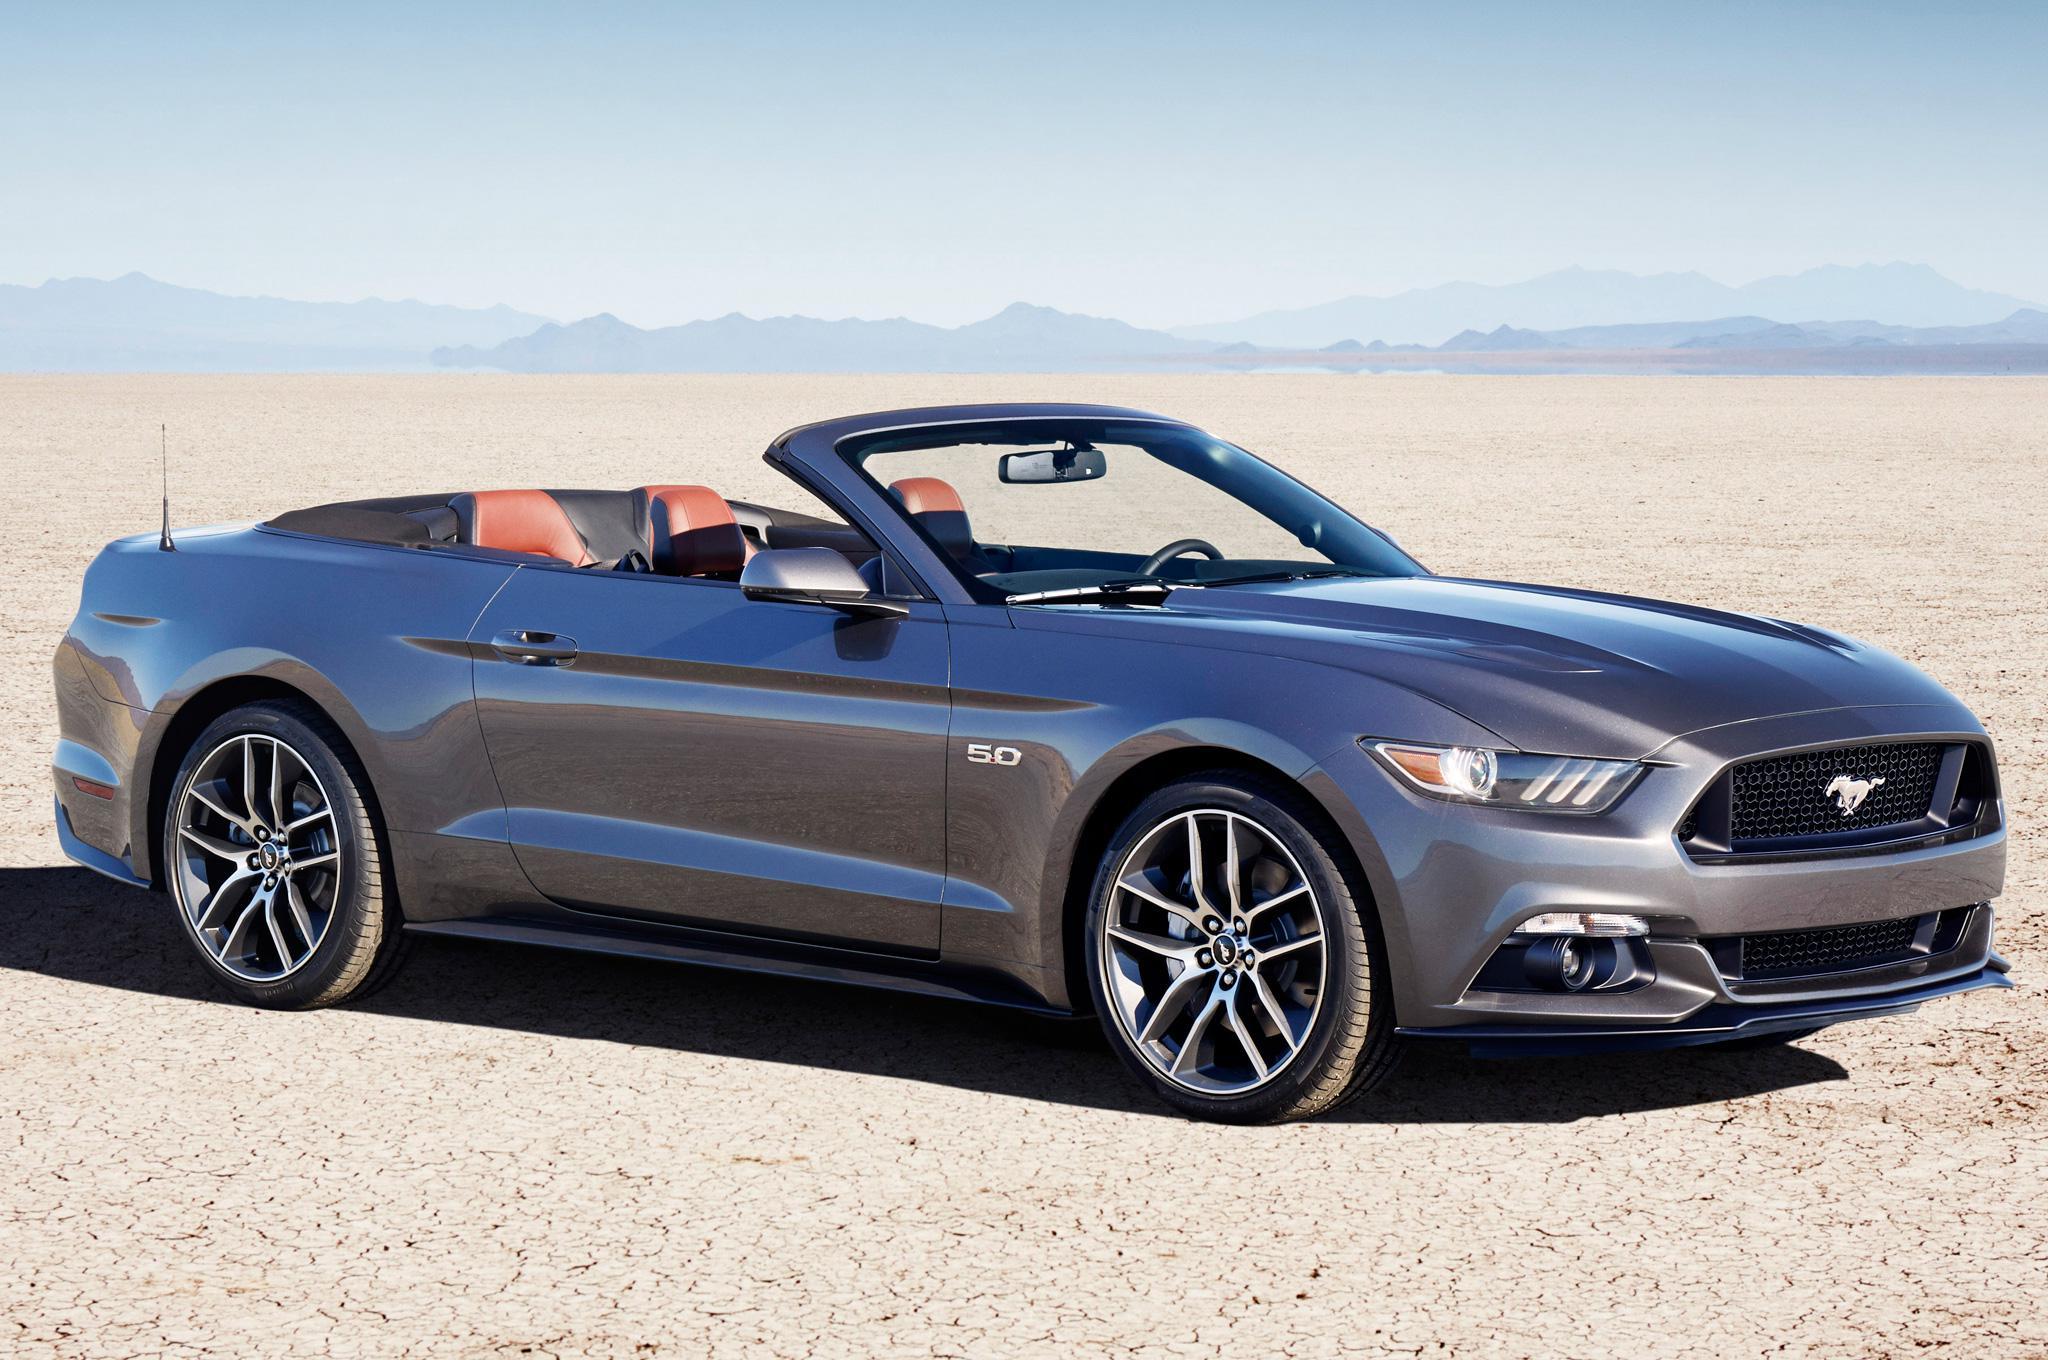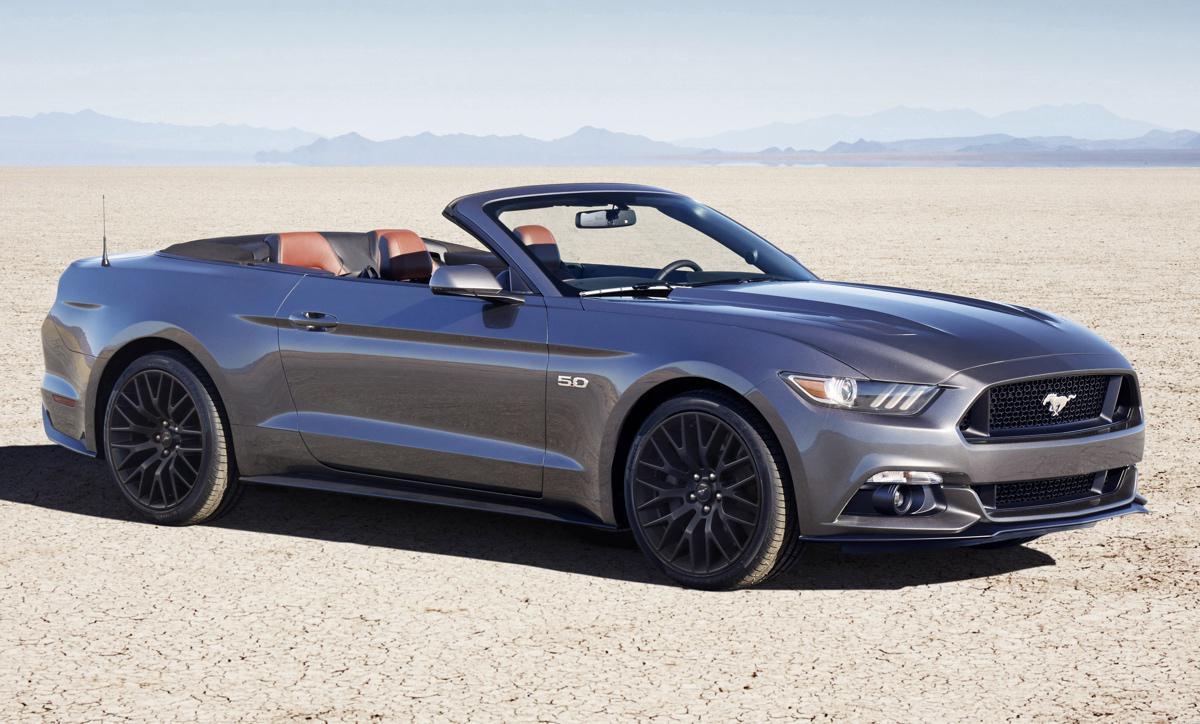The first image is the image on the left, the second image is the image on the right. Analyze the images presented: Is the assertion "You can't actually see any of the brakes light areas." valid? Answer yes or no. Yes. The first image is the image on the left, the second image is the image on the right. Given the left and right images, does the statement "One of the convertibles doesn't have the top removed." hold true? Answer yes or no. No. 